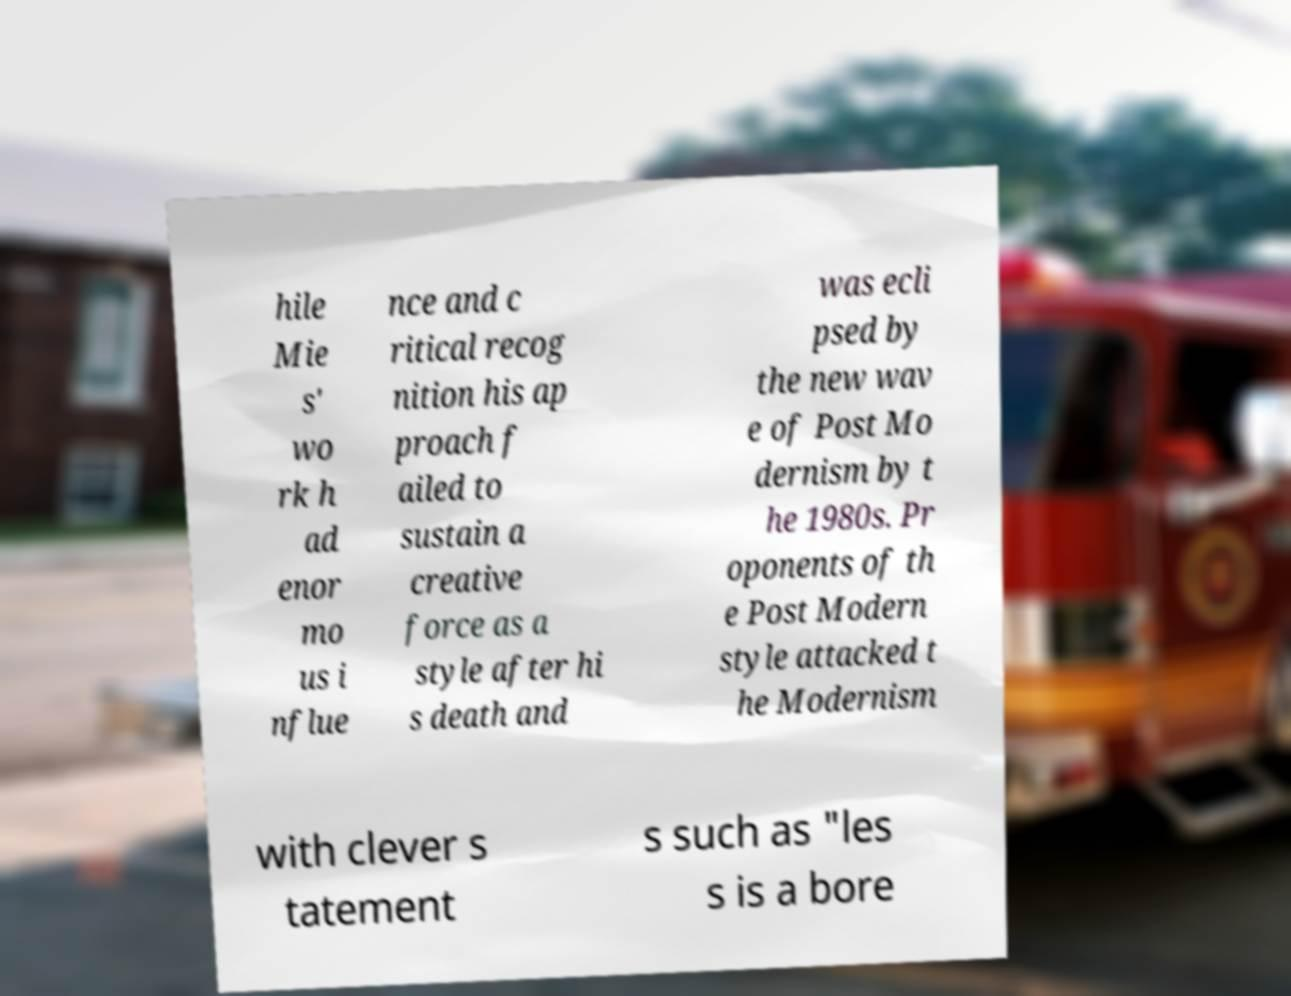Can you accurately transcribe the text from the provided image for me? hile Mie s' wo rk h ad enor mo us i nflue nce and c ritical recog nition his ap proach f ailed to sustain a creative force as a style after hi s death and was ecli psed by the new wav e of Post Mo dernism by t he 1980s. Pr oponents of th e Post Modern style attacked t he Modernism with clever s tatement s such as "les s is a bore 